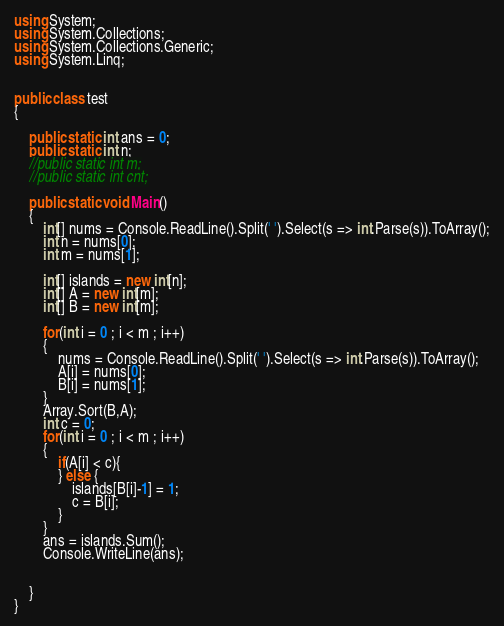Convert code to text. <code><loc_0><loc_0><loc_500><loc_500><_C#_>using System;
using System.Collections;
using System.Collections.Generic;
using System.Linq;


public class test
{	

    public static int ans = 0;
    public static int n;
    //public static int m;
    //public static int cnt;

    public static void Main()
	{
        int[] nums = Console.ReadLine().Split(' ').Select(s => int.Parse(s)).ToArray();
        int n = nums[0];
        int m = nums[1];

        int[] islands = new int[n];
        int[] A = new int[m];
        int[] B = new int[m];

        for(int i = 0 ; i < m ; i++)
        {
            nums = Console.ReadLine().Split(' ').Select(s => int.Parse(s)).ToArray();
            A[i] = nums[0];
            B[i] = nums[1];
        }
        Array.Sort(B,A);
        int c = 0;
        for(int i = 0 ; i < m ; i++)
        {
            if(A[i] < c){
            } else {
                islands[B[i]-1] = 1;
                c = B[i];
            }
        }
        ans = islands.Sum();
        Console.WriteLine(ans);
 
        
    }
}</code> 